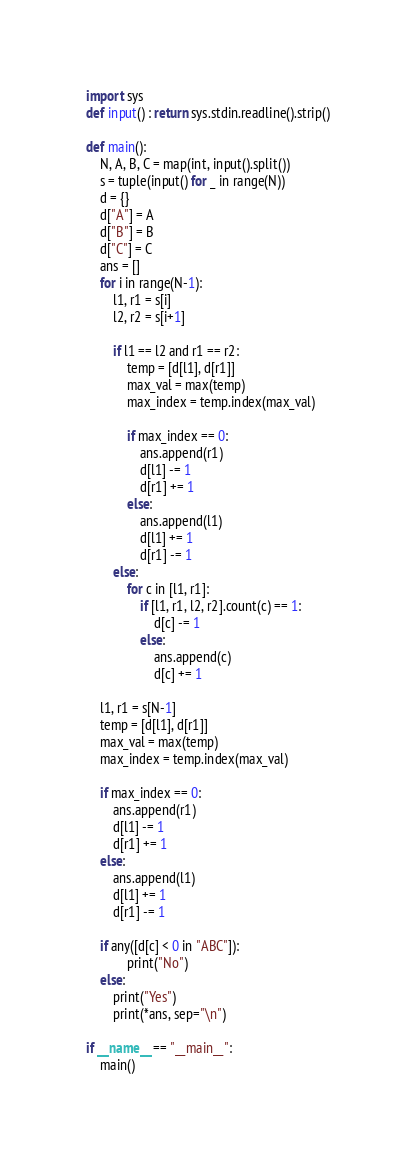Convert code to text. <code><loc_0><loc_0><loc_500><loc_500><_Python_>import sys
def input() : return sys.stdin.readline().strip()

def main():
    N, A, B, C = map(int, input().split())
    s = tuple(input() for _ in range(N))
    d = {}
    d["A"] = A
    d["B"] = B
    d["C"] = C
    ans = []
    for i in range(N-1):
        l1, r1 = s[i]
        l2, r2 = s[i+1]

        if l1 == l2 and r1 == r2:
            temp = [d[l1], d[r1]]
            max_val = max(temp)
            max_index = temp.index(max_val)
            
            if max_index == 0:
                ans.append(r1)
                d[l1] -= 1
                d[r1] += 1
            else:
                ans.append(l1)
                d[l1] += 1
                d[r1] -= 1
        else:
            for c in [l1, r1]:
                if [l1, r1, l2, r2].count(c) == 1:
                    d[c] -= 1
                else:
                    ans.append(c)
                    d[c] += 1

    l1, r1 = s[N-1]
    temp = [d[l1], d[r1]]
    max_val = max(temp)
    max_index = temp.index(max_val)
            
    if max_index == 0:
        ans.append(r1)
        d[l1] -= 1
        d[r1] += 1
    else:
        ans.append(l1)
        d[l1] += 1
        d[r1] -= 1

    if any([d[c] < 0 in "ABC"]):
            print("No")
    else:
        print("Yes")
        print(*ans, sep="\n")

if __name__ == "__main__":
    main()</code> 